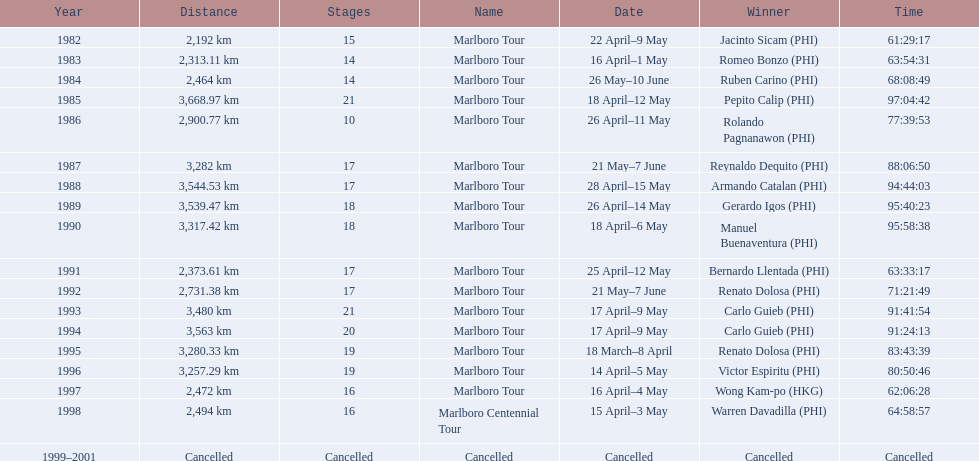Write the full table. {'header': ['Year', 'Distance', 'Stages', 'Name', 'Date', 'Winner', 'Time'], 'rows': [['1982', '2,192\xa0km', '15', 'Marlboro Tour', '22 April–9 May', 'Jacinto Sicam\xa0(PHI)', '61:29:17'], ['1983', '2,313.11\xa0km', '14', 'Marlboro Tour', '16 April–1 May', 'Romeo Bonzo\xa0(PHI)', '63:54:31'], ['1984', '2,464\xa0km', '14', 'Marlboro Tour', '26 May–10 June', 'Ruben Carino\xa0(PHI)', '68:08:49'], ['1985', '3,668.97\xa0km', '21', 'Marlboro Tour', '18 April–12 May', 'Pepito Calip\xa0(PHI)', '97:04:42'], ['1986', '2,900.77\xa0km', '10', 'Marlboro Tour', '26 April–11 May', 'Rolando Pagnanawon\xa0(PHI)', '77:39:53'], ['1987', '3,282\xa0km', '17', 'Marlboro Tour', '21 May–7 June', 'Reynaldo Dequito\xa0(PHI)', '88:06:50'], ['1988', '3,544.53\xa0km', '17', 'Marlboro Tour', '28 April–15 May', 'Armando Catalan\xa0(PHI)', '94:44:03'], ['1989', '3,539.47\xa0km', '18', 'Marlboro Tour', '26 April–14 May', 'Gerardo Igos\xa0(PHI)', '95:40:23'], ['1990', '3,317.42\xa0km', '18', 'Marlboro Tour', '18 April–6 May', 'Manuel Buenaventura\xa0(PHI)', '95:58:38'], ['1991', '2,373.61\xa0km', '17', 'Marlboro Tour', '25 April–12 May', 'Bernardo Llentada\xa0(PHI)', '63:33:17'], ['1992', '2,731.38\xa0km', '17', 'Marlboro Tour', '21 May–7 June', 'Renato Dolosa\xa0(PHI)', '71:21:49'], ['1993', '3,480\xa0km', '21', 'Marlboro Tour', '17 April–9 May', 'Carlo Guieb\xa0(PHI)', '91:41:54'], ['1994', '3,563\xa0km', '20', 'Marlboro Tour', '17 April–9 May', 'Carlo Guieb\xa0(PHI)', '91:24:13'], ['1995', '3,280.33\xa0km', '19', 'Marlboro Tour', '18 March–8 April', 'Renato Dolosa\xa0(PHI)', '83:43:39'], ['1996', '3,257.29\xa0km', '19', 'Marlboro Tour', '14 April–5 May', 'Victor Espiritu\xa0(PHI)', '80:50:46'], ['1997', '2,472\xa0km', '16', 'Marlboro Tour', '16 April–4 May', 'Wong Kam-po\xa0(HKG)', '62:06:28'], ['1998', '2,494\xa0km', '16', 'Marlboro Centennial Tour', '15 April–3 May', 'Warren Davadilla\xa0(PHI)', '64:58:57'], ['1999–2001', 'Cancelled', 'Cancelled', 'Cancelled', 'Cancelled', 'Cancelled', 'Cancelled']]} What was the total number of winners before the tour was canceled? 17. 